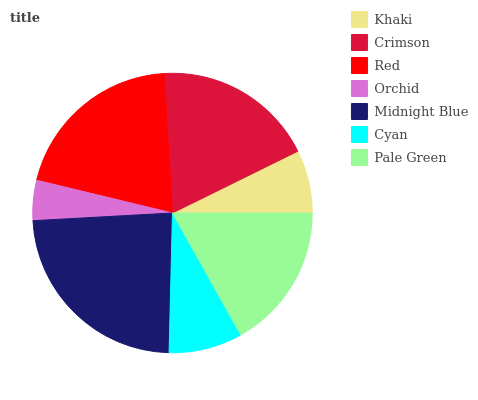Is Orchid the minimum?
Answer yes or no. Yes. Is Midnight Blue the maximum?
Answer yes or no. Yes. Is Crimson the minimum?
Answer yes or no. No. Is Crimson the maximum?
Answer yes or no. No. Is Crimson greater than Khaki?
Answer yes or no. Yes. Is Khaki less than Crimson?
Answer yes or no. Yes. Is Khaki greater than Crimson?
Answer yes or no. No. Is Crimson less than Khaki?
Answer yes or no. No. Is Pale Green the high median?
Answer yes or no. Yes. Is Pale Green the low median?
Answer yes or no. Yes. Is Crimson the high median?
Answer yes or no. No. Is Midnight Blue the low median?
Answer yes or no. No. 